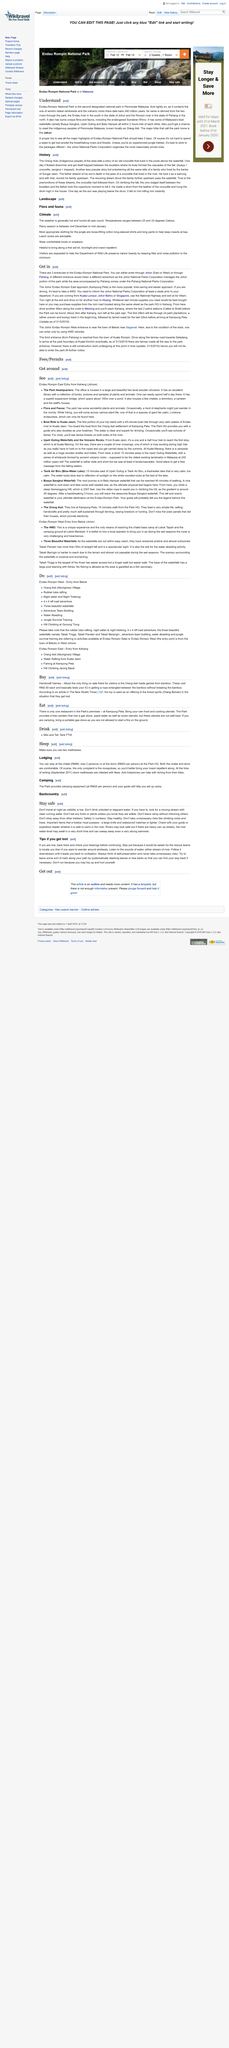Specify some key components in this picture. A proper trip to Peninsular Malaysia's second designated national park should last for at least 3 days in order to see all of its major highlights. If one finds themselves lost, I recommend listening to the soothing sounds of flowing water, whether it be a stream or a river. If you drink unboiled or stagnant water, you must beware of its potentially harmful effects. Look for a moving stream or clear running water to ensure that the water is safe to consume. The Johor National Parks Corporation organizes the most reasonably priced trekking packages among all corporations. The Endau-Rompin National Park is home to the critically endangered Sumatran Rhino, one of the world's most rare and vulnerable animal species. 